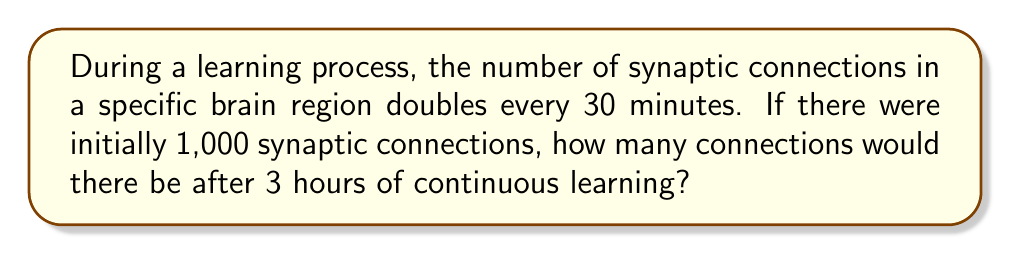Give your solution to this math problem. Let's approach this step-by-step:

1) First, we need to determine how many doubling periods occur in 3 hours:
   - 3 hours = 180 minutes
   - Number of 30-minute periods in 180 minutes: 180 ÷ 30 = 6

2) Now, we can set up our exponential equation:
   $$ y = 1000 \cdot 2^6 $$
   Where:
   - 1000 is the initial number of synaptic connections
   - 2 is our base (doubling each period)
   - 6 is our exponent (number of doubling periods)

3) Let's calculate:
   $$ y = 1000 \cdot 2^6 $$
   $$ y = 1000 \cdot 64 $$
   $$ y = 64,000 $$

4) Therefore, after 3 hours of continuous learning, there would be 64,000 synaptic connections in the specific brain region.
Answer: 64,000 synaptic connections 